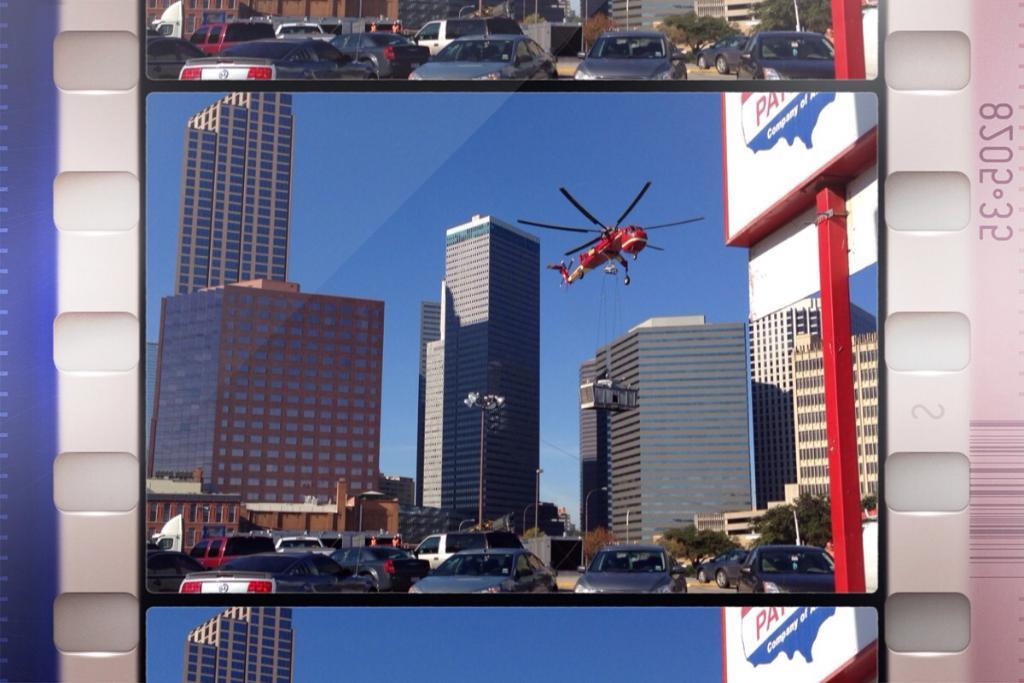What is the main object in the image? The image contains a board. What is depicted on the board? There are vehicles on the road, buildings, and an aircraft in the sky depicted on the board. What type of appliance can be seen in the image? There is no appliance present in the image; it features a board with vehicles, buildings, and an aircraft depicted on it. Can you tell me how many donkeys are visible in the image? There are no donkeys present in the image. 